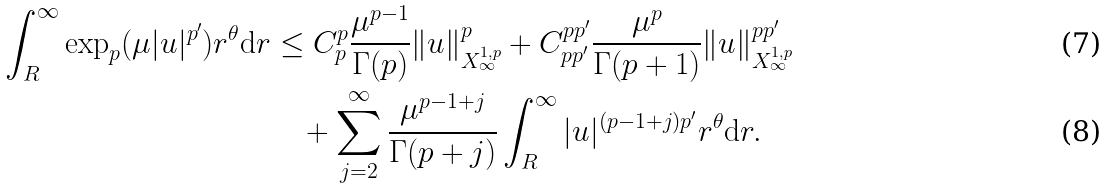<formula> <loc_0><loc_0><loc_500><loc_500>\int _ { R } ^ { \infty } \exp _ { p } ( \mu | u | ^ { p ^ { \prime } } ) r ^ { \theta } \mathrm d r & \leq C _ { p } ^ { p } \frac { \mu ^ { p - 1 } } { \Gamma ( p ) } \| u \| _ { X ^ { 1 , p } _ { \infty } } ^ { p } + C _ { p p ^ { \prime } } ^ { p p ^ { \prime } } \frac { \mu ^ { p } } { \Gamma ( p + 1 ) } \| u \| _ { X ^ { 1 , p } _ { \infty } } ^ { p p ^ { \prime } } \\ & \quad + \sum _ { j = 2 } ^ { \infty } \frac { \mu ^ { p - 1 + j } } { \Gamma ( p + j ) } \int _ { R } ^ { \infty } | u | ^ { ( p - 1 + j ) p ^ { \prime } } r ^ { \theta } \mathrm d r .</formula> 